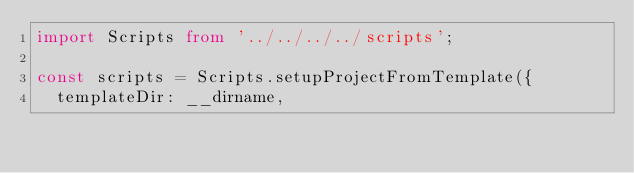Convert code to text. <code><loc_0><loc_0><loc_500><loc_500><_TypeScript_>import Scripts from '../../../../scripts';

const scripts = Scripts.setupProjectFromTemplate({
  templateDir: __dirname,</code> 